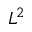Convert formula to latex. <formula><loc_0><loc_0><loc_500><loc_500>L ^ { 2 }</formula> 